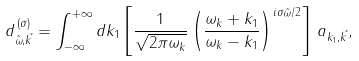<formula> <loc_0><loc_0><loc_500><loc_500>d _ { \tilde { \omega } , \vec { k } } ^ { \, ( \sigma ) } = \int _ { - \infty } ^ { + \infty } d k _ { 1 } \left [ \frac { 1 } { \sqrt { 2 \pi \omega _ { k } } } \left ( \frac { \omega _ { k } + k _ { 1 } } { \omega _ { k } - k _ { 1 } } \right ) ^ { i \sigma \tilde { \omega } / 2 } \right ] \, a _ { k _ { 1 } , \vec { k } } ,</formula> 